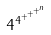Convert formula to latex. <formula><loc_0><loc_0><loc_500><loc_500>4 ^ { 4 ^ { + ^ { + ^ { + ^ { n } } } } }</formula> 